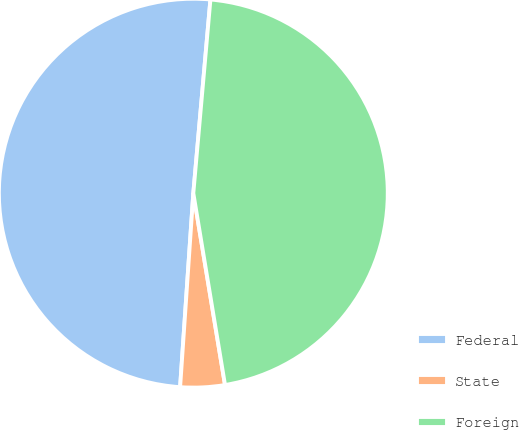Convert chart. <chart><loc_0><loc_0><loc_500><loc_500><pie_chart><fcel>Federal<fcel>State<fcel>Foreign<nl><fcel>50.32%<fcel>3.69%<fcel>45.99%<nl></chart> 